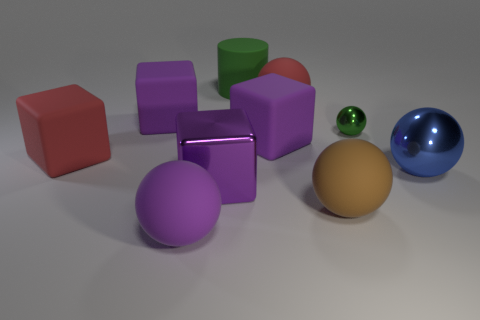Are there any other things that are the same size as the red rubber ball?
Your response must be concise. Yes. There is a red matte object in front of the small green object; is it the same shape as the big green object?
Ensure brevity in your answer.  No. Is the number of big purple matte objects that are behind the green rubber cylinder greater than the number of tiny spheres?
Keep it short and to the point. No. What is the color of the ball to the left of the block to the right of the big green cylinder?
Your answer should be compact. Purple. How many large purple rubber things are there?
Your answer should be compact. 3. How many big matte objects are both to the right of the purple sphere and behind the small green metal sphere?
Ensure brevity in your answer.  2. Is there any other thing that is the same shape as the tiny thing?
Offer a very short reply. Yes. Does the cylinder have the same color as the block that is right of the big green matte thing?
Offer a very short reply. No. There is a large red rubber object that is in front of the small ball; what is its shape?
Offer a terse response. Cube. How many other objects are there of the same material as the cylinder?
Ensure brevity in your answer.  6. 